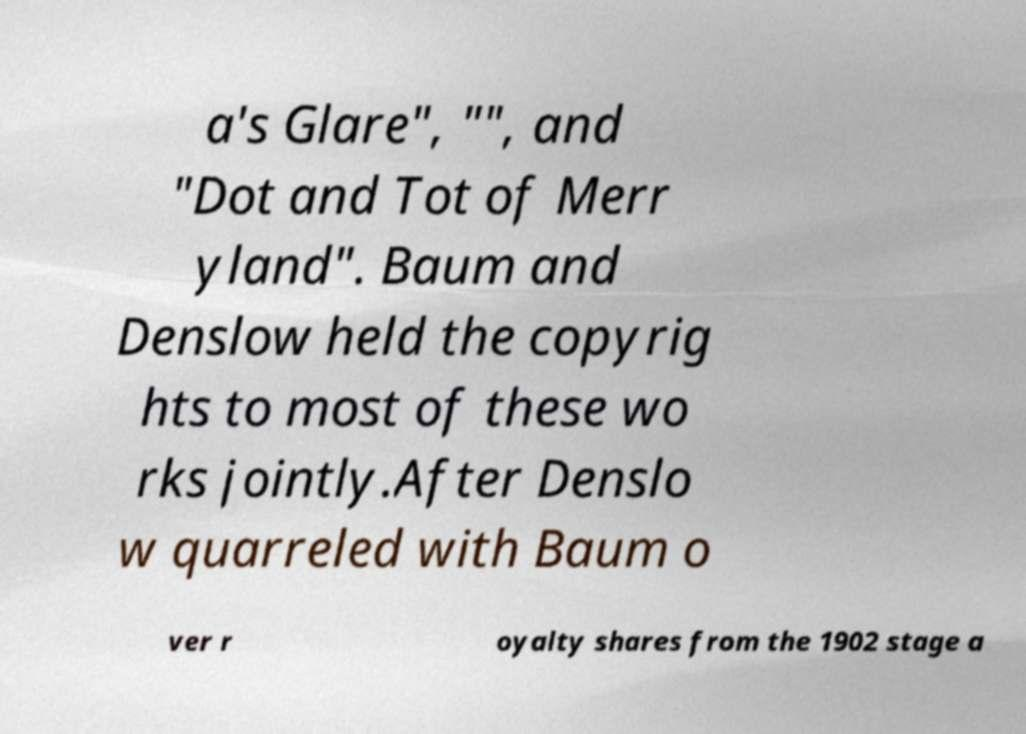I need the written content from this picture converted into text. Can you do that? a's Glare", "", and "Dot and Tot of Merr yland". Baum and Denslow held the copyrig hts to most of these wo rks jointly.After Denslo w quarreled with Baum o ver r oyalty shares from the 1902 stage a 